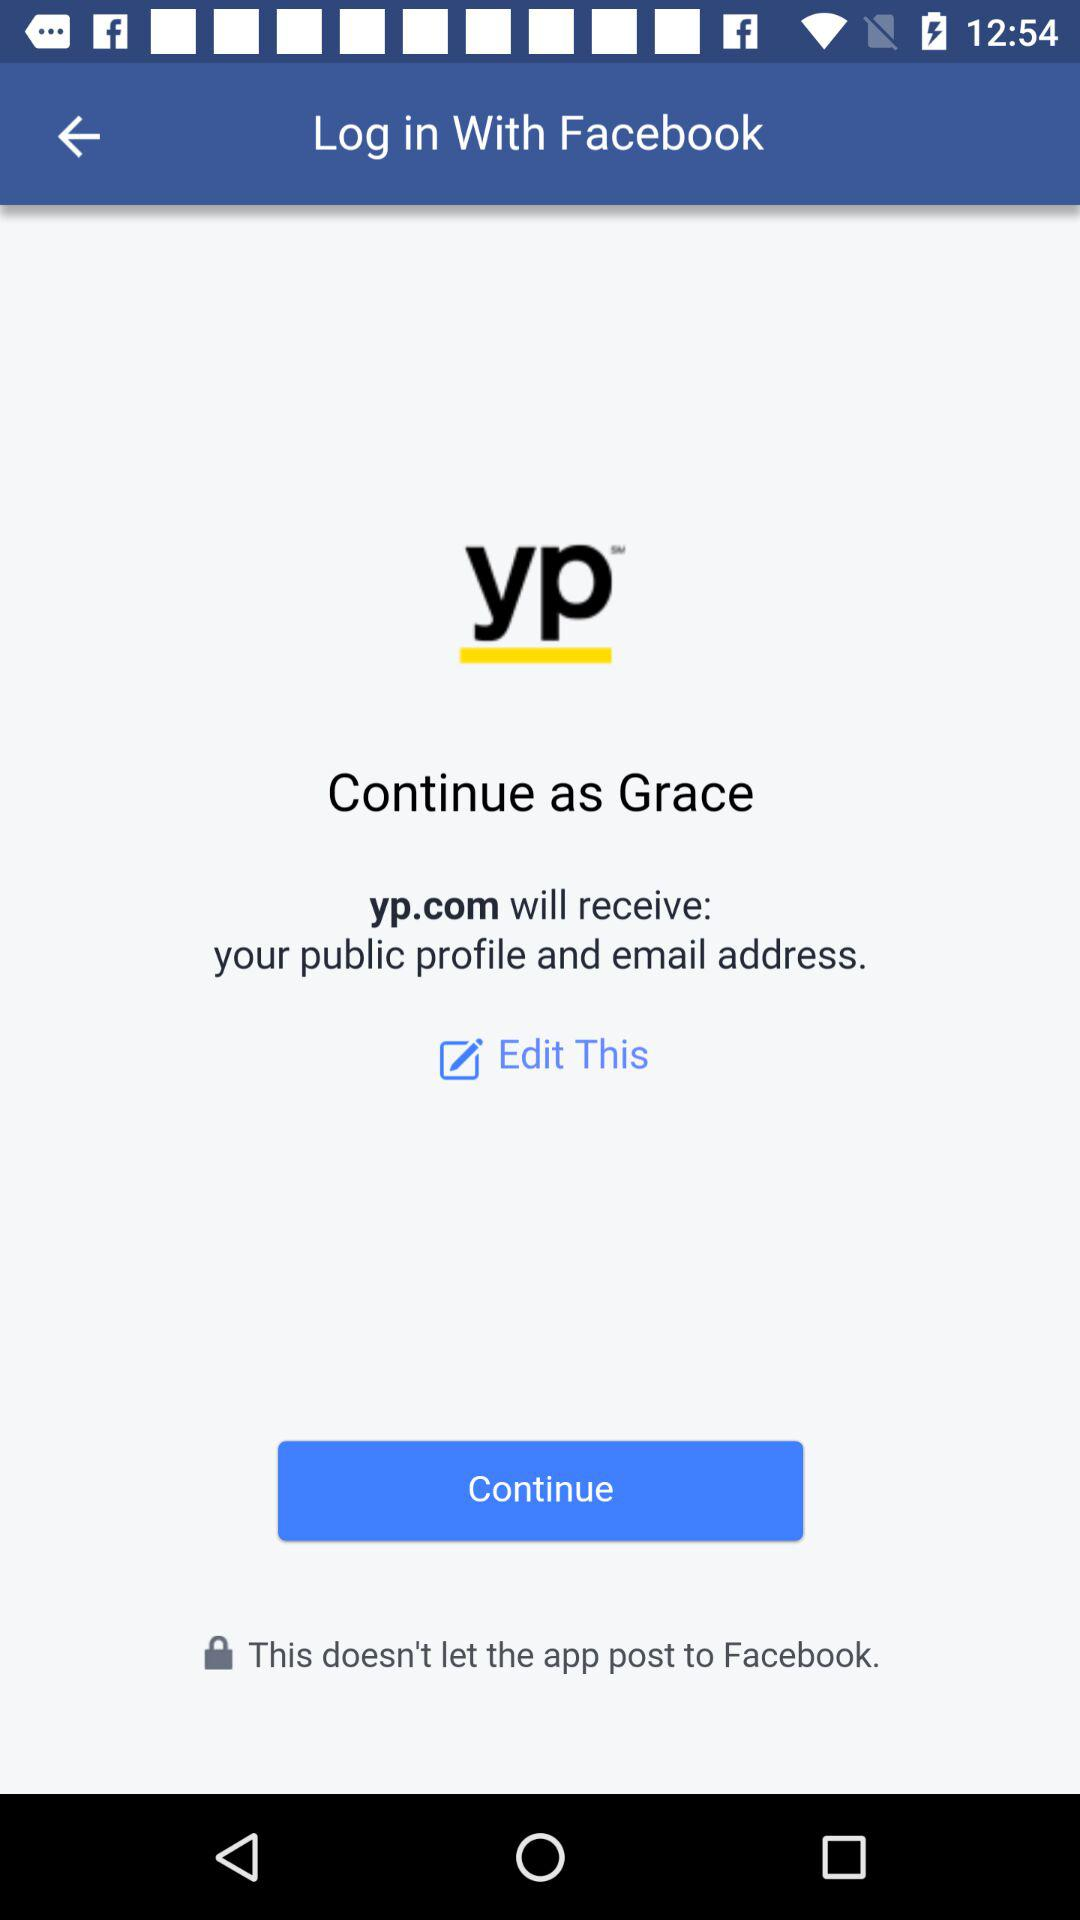Through what application is the person logging in? The person is logging in through "Facebook". 